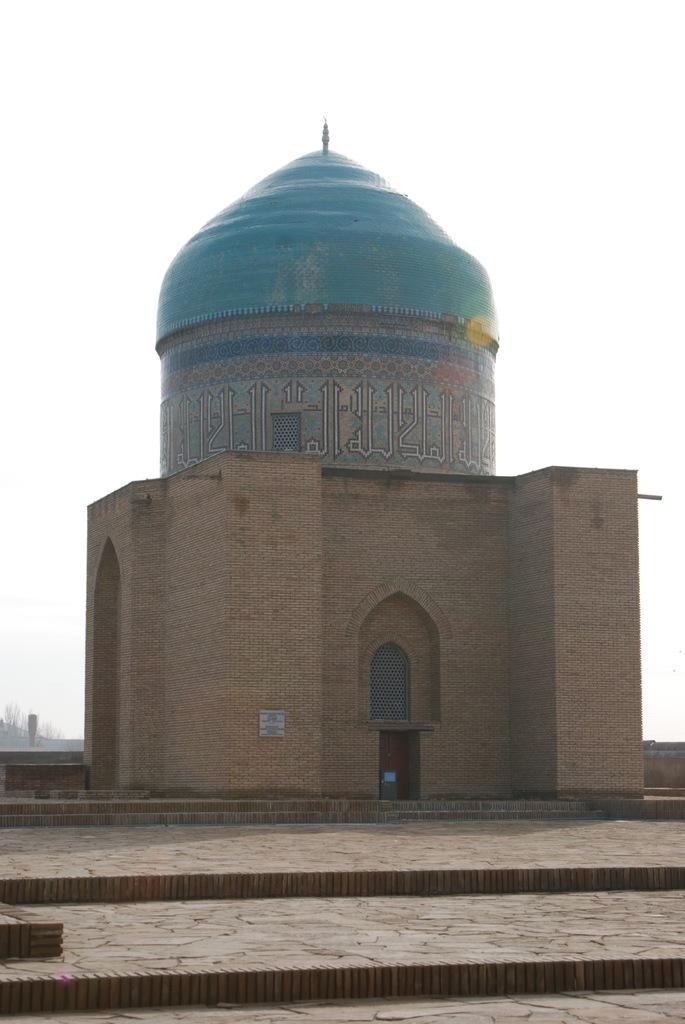How would you summarize this image in a sentence or two? In this picture there is a dome in the center of the image and there are flat stairs at the bottom side of the image. 